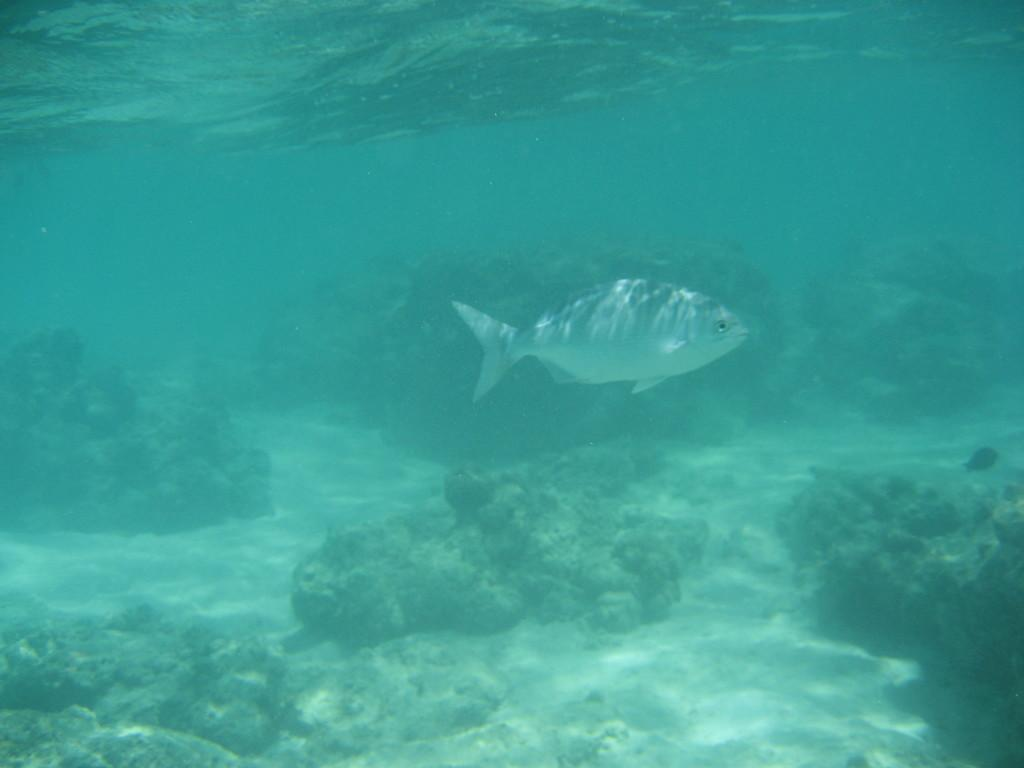What is present in the water in the image? There is a deep in the water, sand, water stones, and a fish in the water. What type of material is present in the water along with the deep? There is sand and water stones present in the water along with the deep. What kind of animal can be seen in the water? There is a fish in the water. What is the color of the fish in the image? The fish is white in color. Can you see any crayons being used to draw in the water? There are no crayons present in the image, and they are not being used to draw in the water. Are there any bees flying around the fish in the water? There are no bees present in the image, and they are not flying around the fish in the water. 